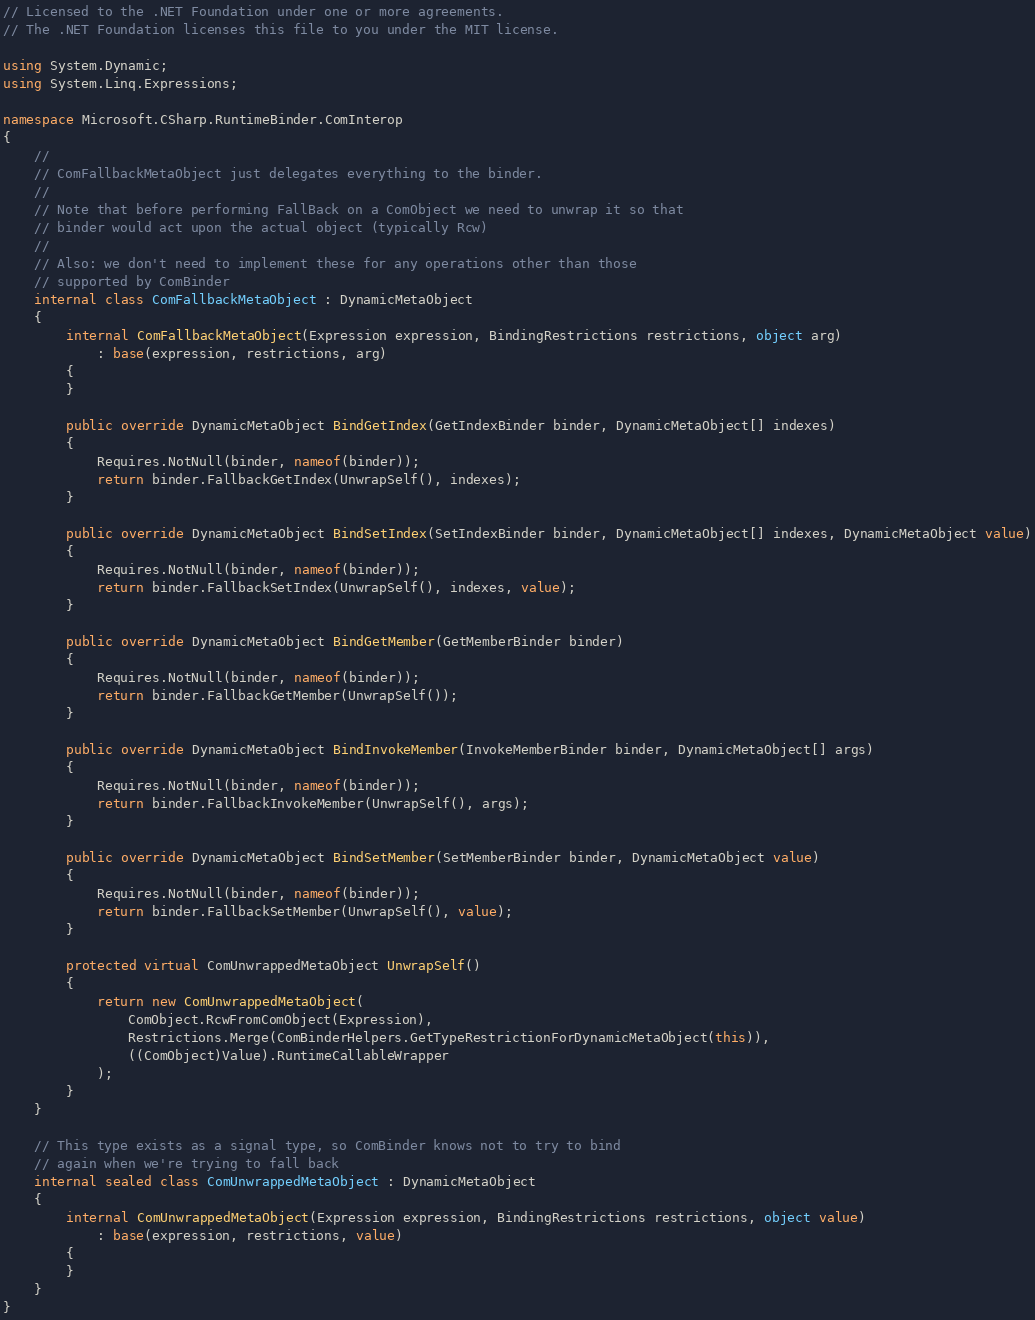Convert code to text. <code><loc_0><loc_0><loc_500><loc_500><_C#_>// Licensed to the .NET Foundation under one or more agreements.
// The .NET Foundation licenses this file to you under the MIT license.

using System.Dynamic;
using System.Linq.Expressions;

namespace Microsoft.CSharp.RuntimeBinder.ComInterop
{
    //
    // ComFallbackMetaObject just delegates everything to the binder.
    //
    // Note that before performing FallBack on a ComObject we need to unwrap it so that
    // binder would act upon the actual object (typically Rcw)
    //
    // Also: we don't need to implement these for any operations other than those
    // supported by ComBinder
    internal class ComFallbackMetaObject : DynamicMetaObject
    {
        internal ComFallbackMetaObject(Expression expression, BindingRestrictions restrictions, object arg)
            : base(expression, restrictions, arg)
        {
        }

        public override DynamicMetaObject BindGetIndex(GetIndexBinder binder, DynamicMetaObject[] indexes)
        {
            Requires.NotNull(binder, nameof(binder));
            return binder.FallbackGetIndex(UnwrapSelf(), indexes);
        }

        public override DynamicMetaObject BindSetIndex(SetIndexBinder binder, DynamicMetaObject[] indexes, DynamicMetaObject value)
        {
            Requires.NotNull(binder, nameof(binder));
            return binder.FallbackSetIndex(UnwrapSelf(), indexes, value);
        }

        public override DynamicMetaObject BindGetMember(GetMemberBinder binder)
        {
            Requires.NotNull(binder, nameof(binder));
            return binder.FallbackGetMember(UnwrapSelf());
        }

        public override DynamicMetaObject BindInvokeMember(InvokeMemberBinder binder, DynamicMetaObject[] args)
        {
            Requires.NotNull(binder, nameof(binder));
            return binder.FallbackInvokeMember(UnwrapSelf(), args);
        }

        public override DynamicMetaObject BindSetMember(SetMemberBinder binder, DynamicMetaObject value)
        {
            Requires.NotNull(binder, nameof(binder));
            return binder.FallbackSetMember(UnwrapSelf(), value);
        }

        protected virtual ComUnwrappedMetaObject UnwrapSelf()
        {
            return new ComUnwrappedMetaObject(
                ComObject.RcwFromComObject(Expression),
                Restrictions.Merge(ComBinderHelpers.GetTypeRestrictionForDynamicMetaObject(this)),
                ((ComObject)Value).RuntimeCallableWrapper
            );
        }
    }

    // This type exists as a signal type, so ComBinder knows not to try to bind
    // again when we're trying to fall back
    internal sealed class ComUnwrappedMetaObject : DynamicMetaObject
    {
        internal ComUnwrappedMetaObject(Expression expression, BindingRestrictions restrictions, object value)
            : base(expression, restrictions, value)
        {
        }
    }
}
</code> 